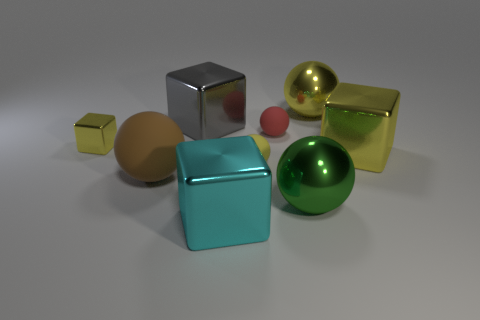The yellow matte object that is the same shape as the tiny red thing is what size? The yellow object, which shares its cylindrical shape with the smaller red object, appears to be small in size, in the context of the objects within the image. 